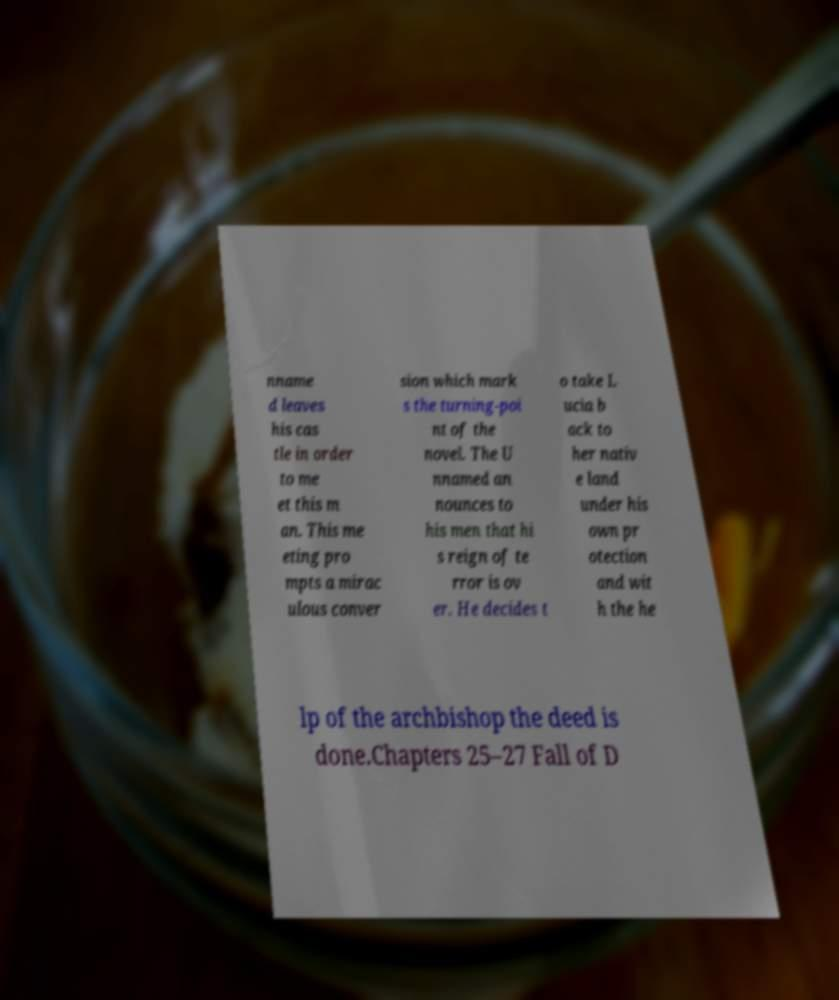Can you read and provide the text displayed in the image?This photo seems to have some interesting text. Can you extract and type it out for me? nname d leaves his cas tle in order to me et this m an. This me eting pro mpts a mirac ulous conver sion which mark s the turning-poi nt of the novel. The U nnamed an nounces to his men that hi s reign of te rror is ov er. He decides t o take L ucia b ack to her nativ e land under his own pr otection and wit h the he lp of the archbishop the deed is done.Chapters 25–27 Fall of D 